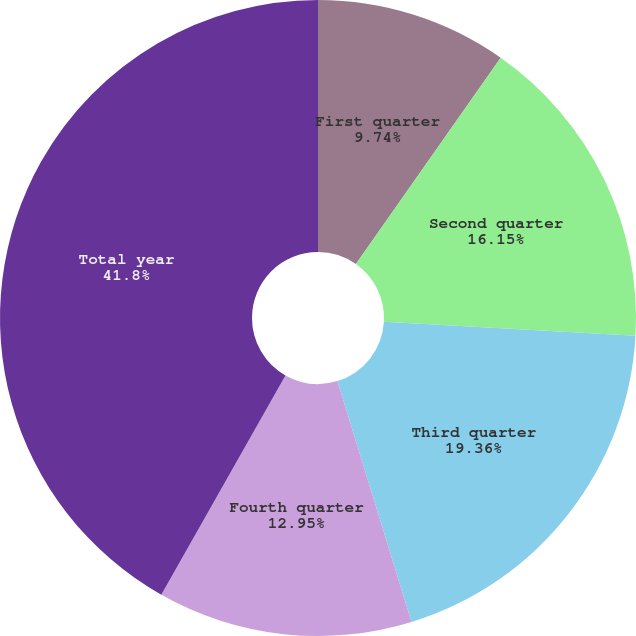Convert chart to OTSL. <chart><loc_0><loc_0><loc_500><loc_500><pie_chart><fcel>First quarter<fcel>Second quarter<fcel>Third quarter<fcel>Fourth quarter<fcel>Total year<nl><fcel>9.74%<fcel>16.15%<fcel>19.36%<fcel>12.95%<fcel>41.8%<nl></chart> 